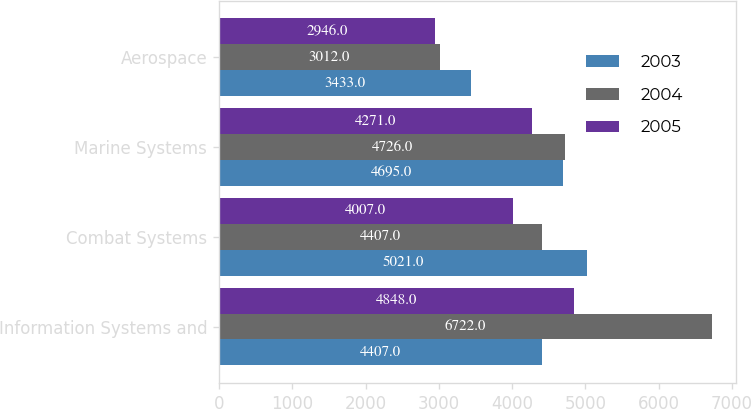Convert chart. <chart><loc_0><loc_0><loc_500><loc_500><stacked_bar_chart><ecel><fcel>Information Systems and<fcel>Combat Systems<fcel>Marine Systems<fcel>Aerospace<nl><fcel>2003<fcel>4407<fcel>5021<fcel>4695<fcel>3433<nl><fcel>2004<fcel>6722<fcel>4407<fcel>4726<fcel>3012<nl><fcel>2005<fcel>4848<fcel>4007<fcel>4271<fcel>2946<nl></chart> 